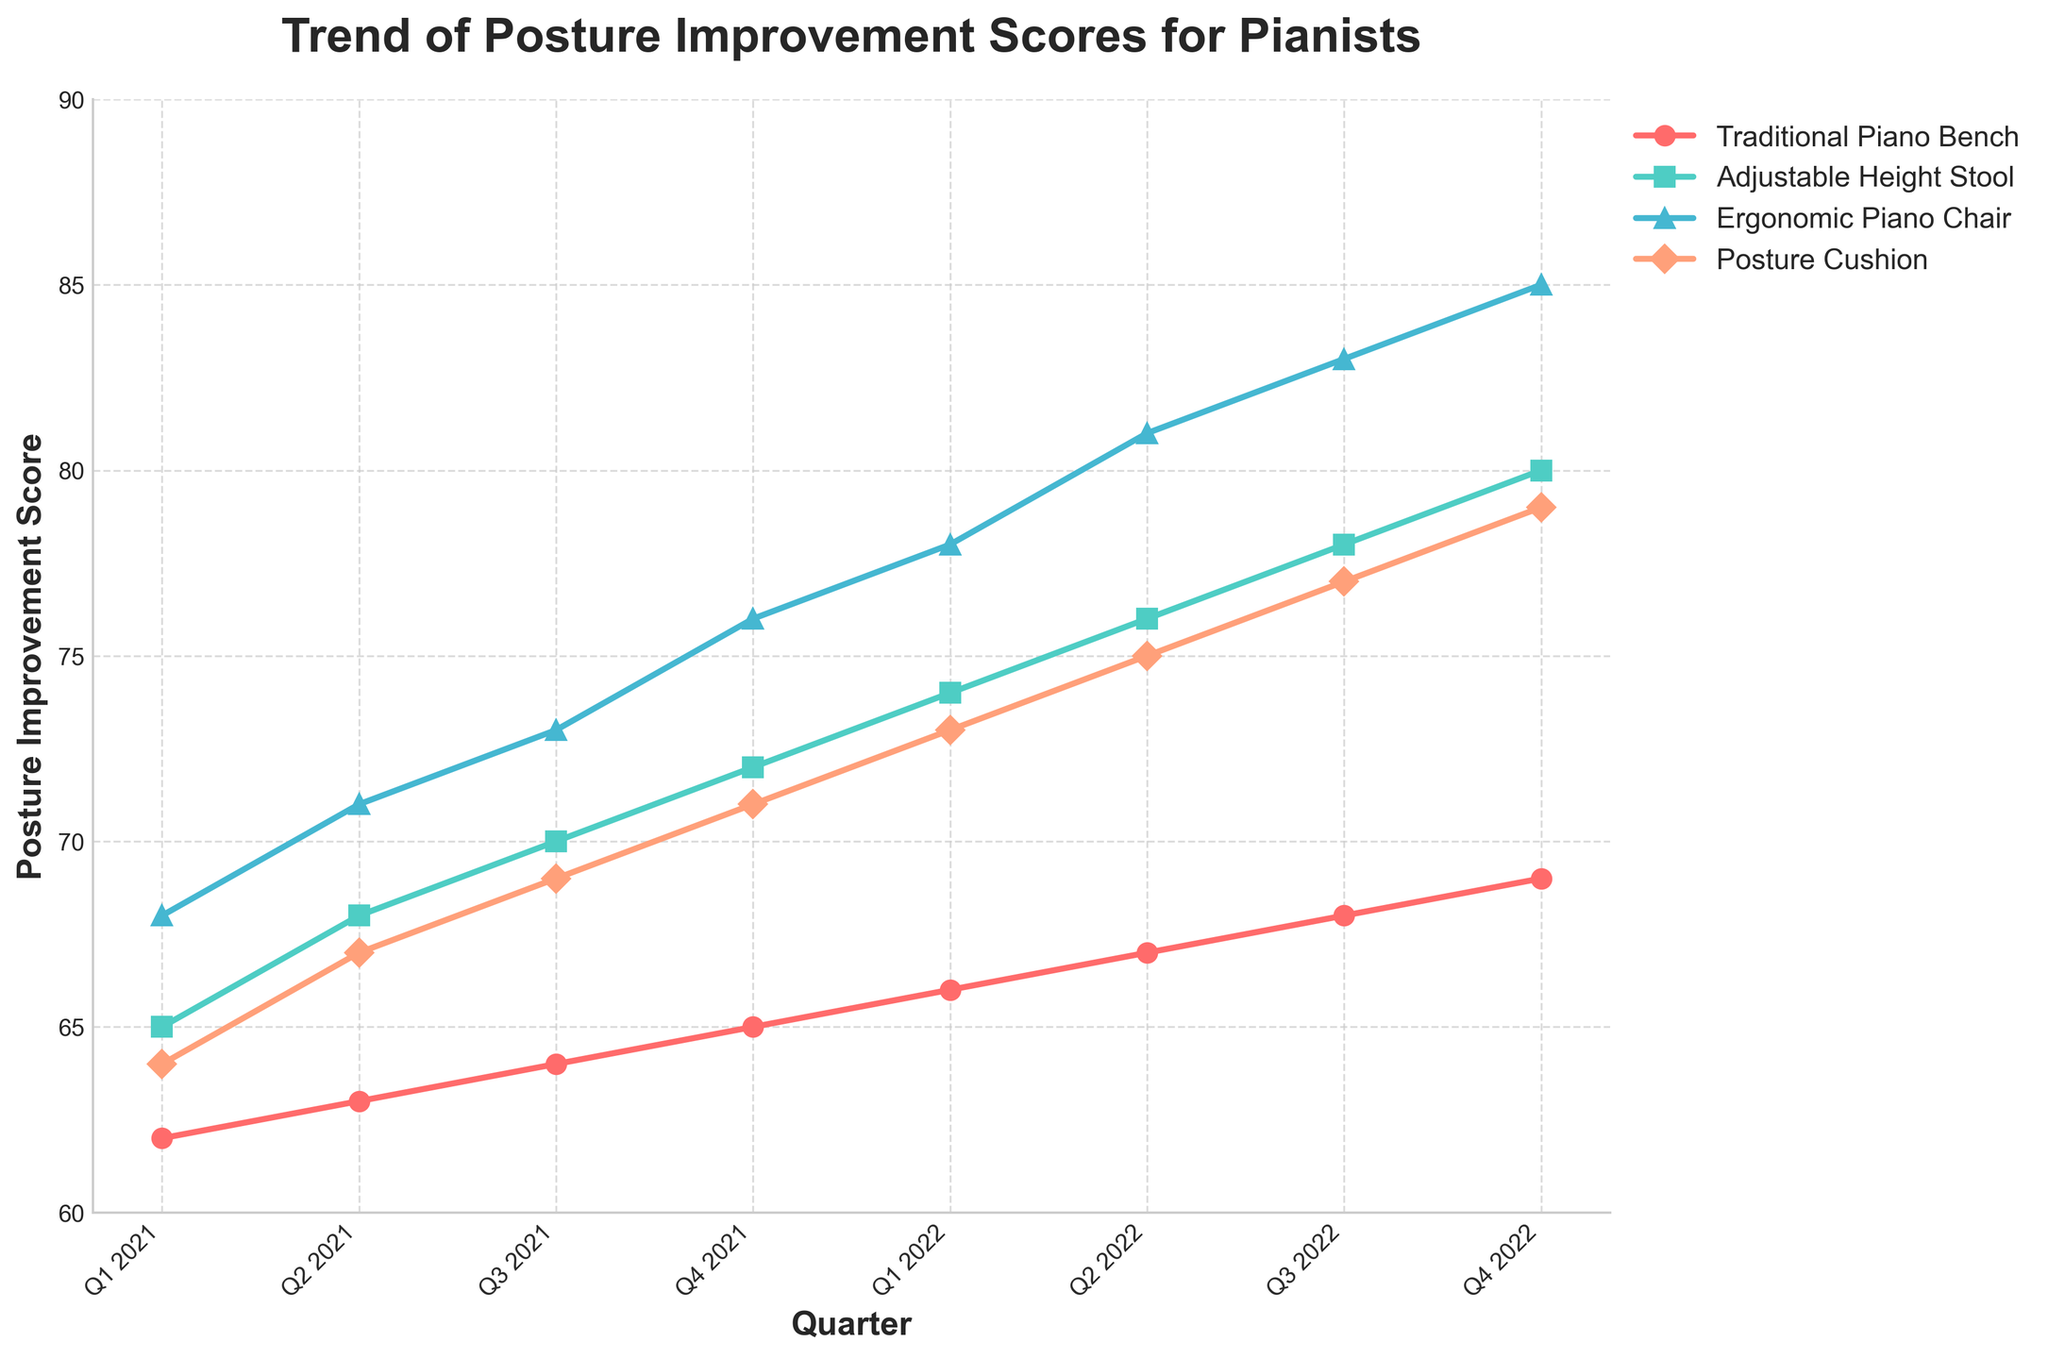Which seating solution showed the greatest improvement from Q1 2021 to Q4 2022? To determine which seating solution showed the greatest improvement, calculate the difference in scores from Q1 2021 to Q4 2022 for each solution. Traditional Piano Bench: 69-62 = 7, Adjustable Height Stool: 80-65 = 15, Ergonomic Piano Chair: 85-68 = 17, Posture Cushion: 79-64 = 15. The Ergonomic Piano Chair displayed the greatest improvement.
Answer: Ergonomic Piano Chair Which seating solution had the highest posture improvement score in Q2 2022? To find the highest posture improvement score in Q2 2022, compare the scores of all solutions in that quarter. Traditional Piano Bench: 67, Adjustable Height Stool: 76, Ergonomic Piano Chair: 81, Posture Cushion: 75. Ergonomic Piano Chair had the highest score.
Answer: Ergonomic Piano Chair What is the average posture improvement score of the Adjustable Height Stool over the two years? Sum the scores of the Adjustable Height Stool for each quarter over two years and divide by the number of quarters: (65 + 68 + 70 + 72 + 74 + 76 + 78 + 80)/8 = 583/8 = 72.875.
Answer: 72.875 How did the Posture Cushion’s improvement compare to the Ergonomic Piano Chair’s between Q3 2021 and Q1 2022? Calculate the improvement for both from Q3 2021 to Q1 2022. Posture Cushion: 73-69 = 4, Ergonomic Piano Chair: 78-73 = 5. The Ergonomic Piano Chair improved more by 1 point.
Answer: Ergonomic Piano Chair improved more Which quarter did all seating solutions see an increase in posture improvement score compared to the previous quarter? Check each quarter to see if all solutions have higher scores than in the previous period. Q2 2021 (compared to Q1 2021), Q3 2021 (compared to Q2 2021), Q4 2021 (compared to Q3 2021), Q1 2022 (compared to Q4 2021), Q2 2022 (compared to Q1 2022), Q3 2022 (compared to Q2 2022), Q4 2022 (compared to Q3 2022). Hence, every quarter showed improvements.
Answer: All quarters By how many points did the Traditional Piano Bench score increase from Q1 2021 to Q3 2022? The score increase for the Traditional Piano Bench is calculated as follows: 68-62 = 6 points.
Answer: 6 Was there any quarter where the Adjustable Height Stool had the lowest posture improvement score among all seating solutions? For each quarter, compare the Adjustable Height Stool's score to the others. In every quarter, it has scores higher than at least one other seating solution.
Answer: No 